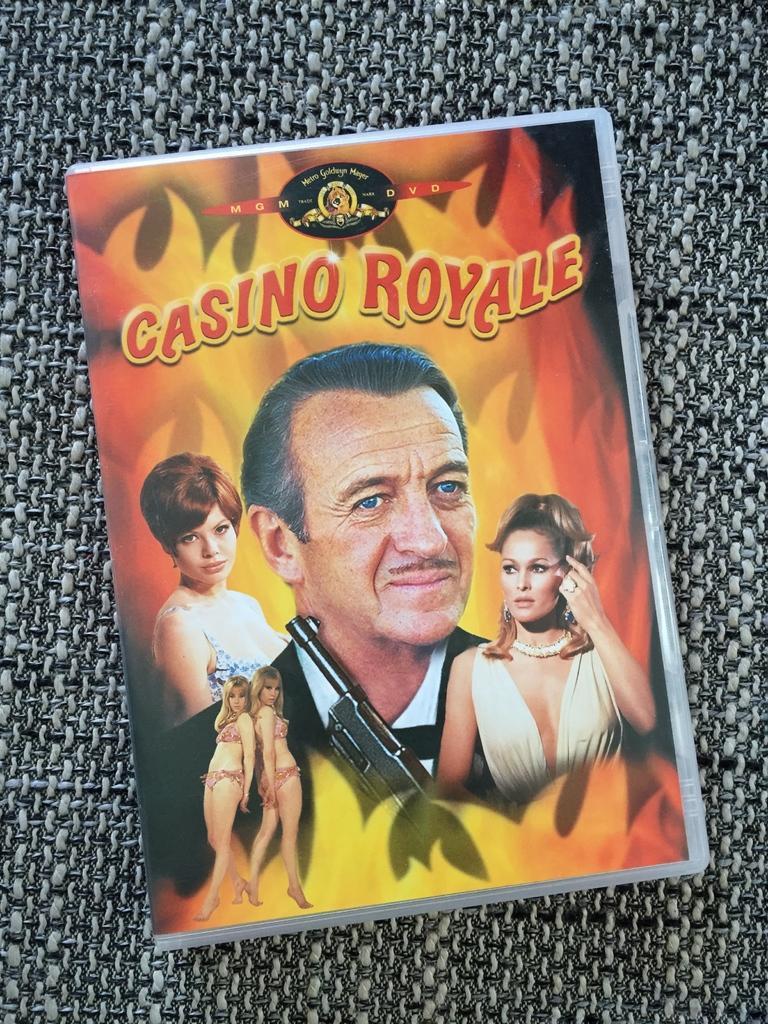Can you describe this image briefly? It's a poster, in this a man is there, beautiful women pictures are there in it. 